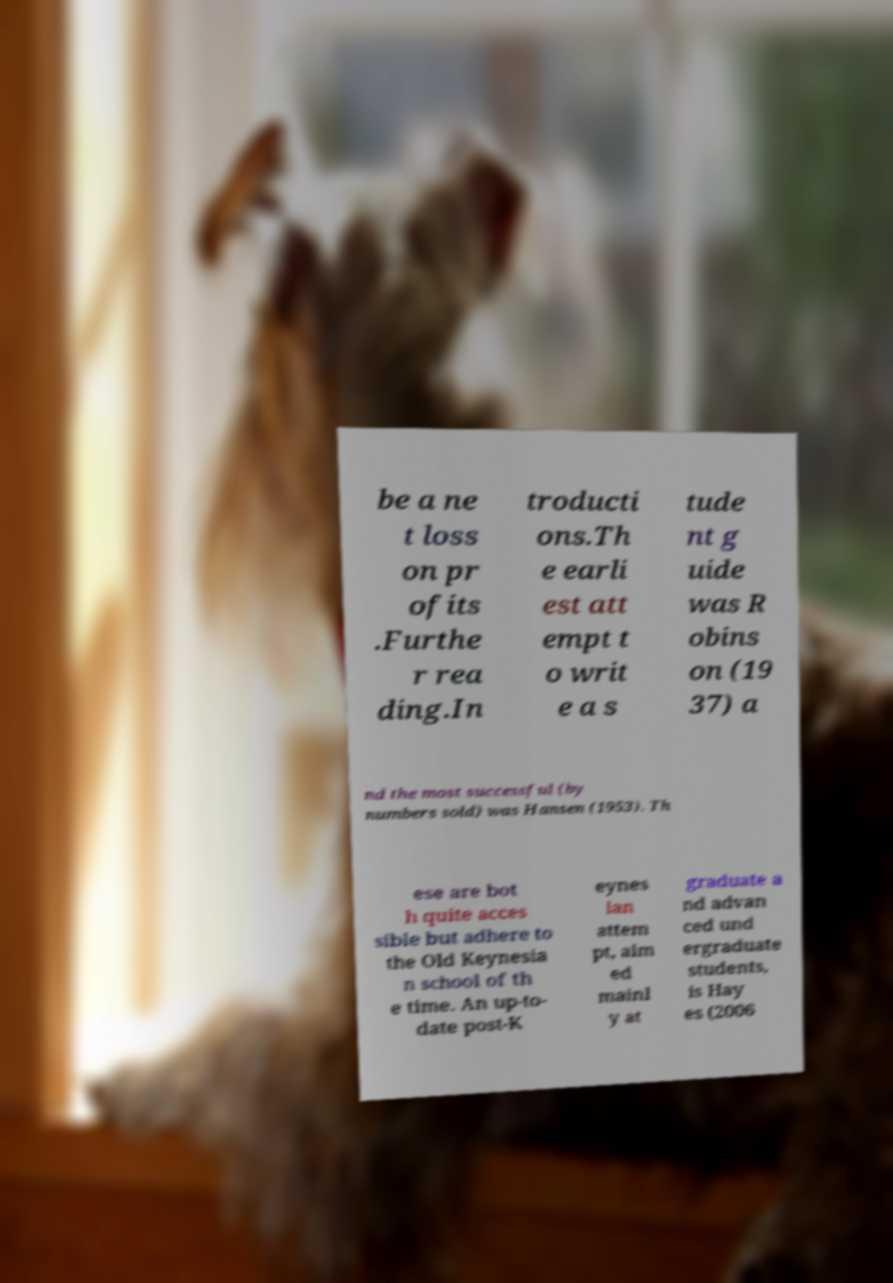Please identify and transcribe the text found in this image. be a ne t loss on pr ofits .Furthe r rea ding.In troducti ons.Th e earli est att empt t o writ e a s tude nt g uide was R obins on (19 37) a nd the most successful (by numbers sold) was Hansen (1953). Th ese are bot h quite acces sible but adhere to the Old Keynesia n school of th e time. An up-to- date post-K eynes ian attem pt, aim ed mainl y at graduate a nd advan ced und ergraduate students, is Hay es (2006 